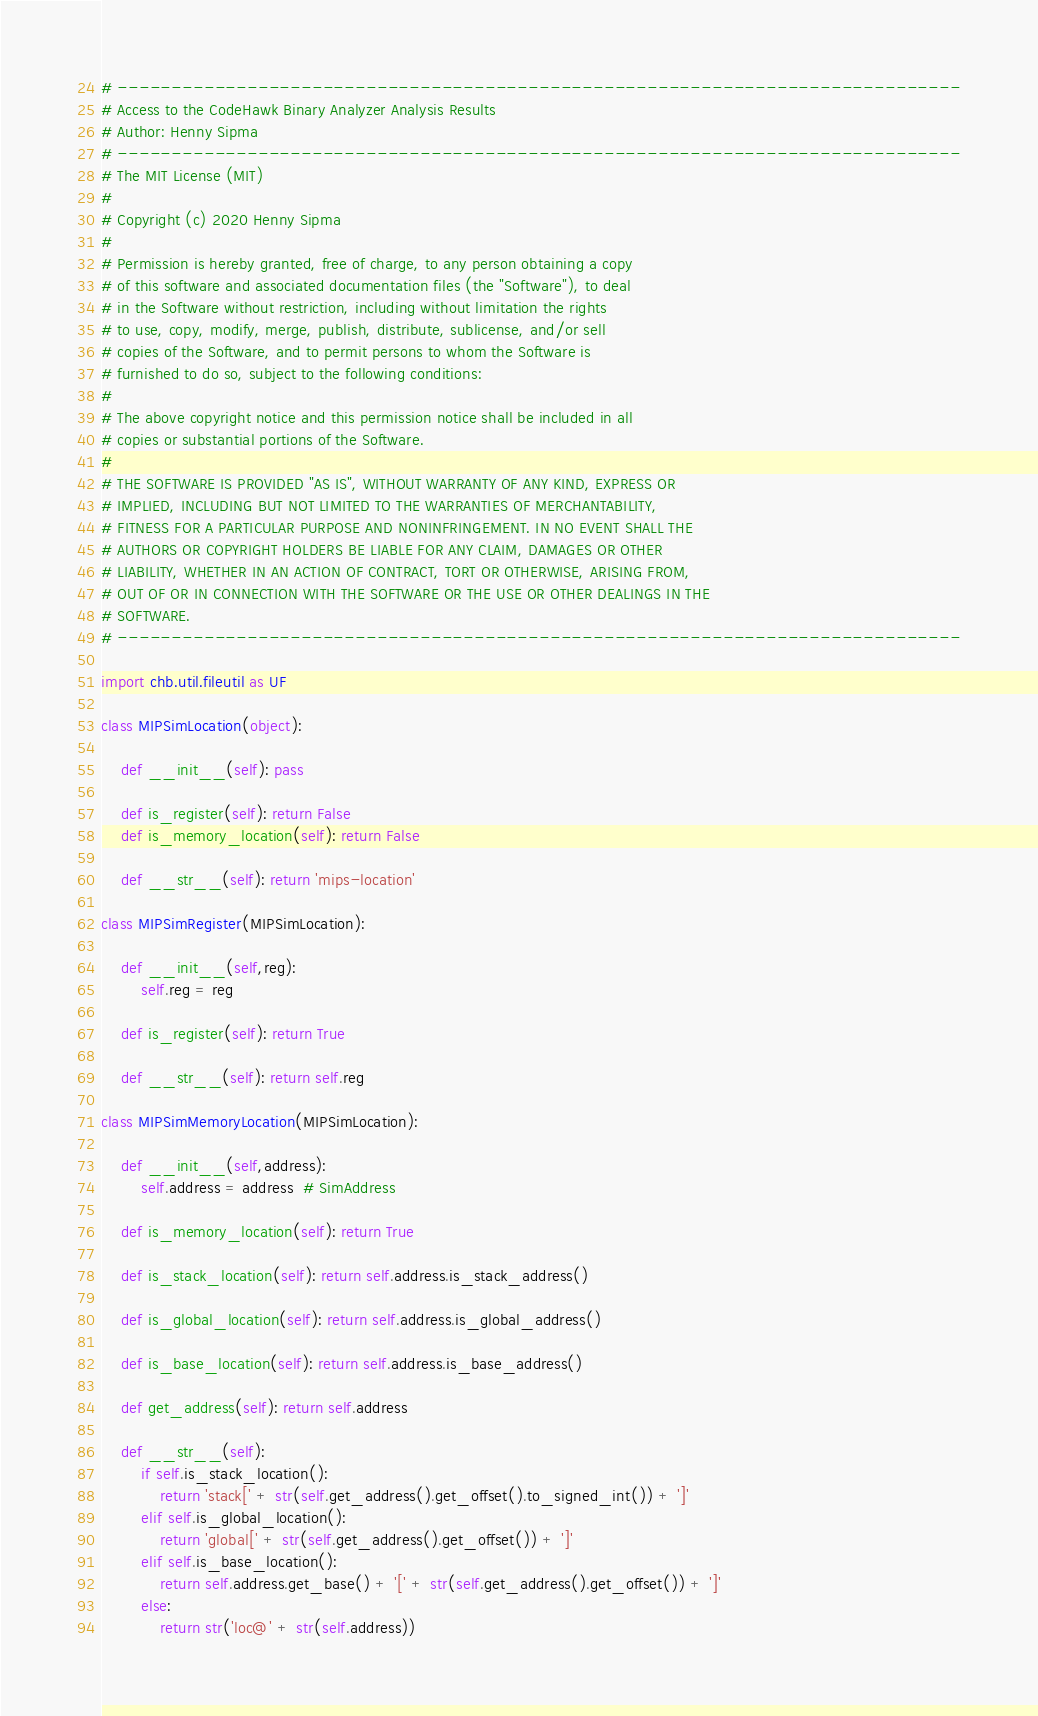Convert code to text. <code><loc_0><loc_0><loc_500><loc_500><_Python_># ------------------------------------------------------------------------------
# Access to the CodeHawk Binary Analyzer Analysis Results
# Author: Henny Sipma
# ------------------------------------------------------------------------------
# The MIT License (MIT)
#
# Copyright (c) 2020 Henny Sipma
#
# Permission is hereby granted, free of charge, to any person obtaining a copy
# of this software and associated documentation files (the "Software"), to deal
# in the Software without restriction, including without limitation the rights
# to use, copy, modify, merge, publish, distribute, sublicense, and/or sell
# copies of the Software, and to permit persons to whom the Software is
# furnished to do so, subject to the following conditions:
#
# The above copyright notice and this permission notice shall be included in all
# copies or substantial portions of the Software.
# 
# THE SOFTWARE IS PROVIDED "AS IS", WITHOUT WARRANTY OF ANY KIND, EXPRESS OR
# IMPLIED, INCLUDING BUT NOT LIMITED TO THE WARRANTIES OF MERCHANTABILITY,
# FITNESS FOR A PARTICULAR PURPOSE AND NONINFRINGEMENT. IN NO EVENT SHALL THE
# AUTHORS OR COPYRIGHT HOLDERS BE LIABLE FOR ANY CLAIM, DAMAGES OR OTHER
# LIABILITY, WHETHER IN AN ACTION OF CONTRACT, TORT OR OTHERWISE, ARISING FROM,
# OUT OF OR IN CONNECTION WITH THE SOFTWARE OR THE USE OR OTHER DEALINGS IN THE
# SOFTWARE.
# ------------------------------------------------------------------------------

import chb.util.fileutil as UF

class MIPSimLocation(object):

    def __init__(self): pass

    def is_register(self): return False
    def is_memory_location(self): return False

    def __str__(self): return 'mips-location'

class MIPSimRegister(MIPSimLocation):

    def __init__(self,reg):
        self.reg = reg

    def is_register(self): return True

    def __str__(self): return self.reg

class MIPSimMemoryLocation(MIPSimLocation):

    def __init__(self,address):
        self.address = address  # SimAddress

    def is_memory_location(self): return True

    def is_stack_location(self): return self.address.is_stack_address()

    def is_global_location(self): return self.address.is_global_address()

    def is_base_location(self): return self.address.is_base_address()

    def get_address(self): return self.address

    def __str__(self):
        if self.is_stack_location():
            return 'stack[' + str(self.get_address().get_offset().to_signed_int()) + ']'
        elif self.is_global_location():
            return 'global[' + str(self.get_address().get_offset()) + ']'
        elif self.is_base_location():
            return self.address.get_base() + '[' + str(self.get_address().get_offset()) + ']'
        else:
            return str('loc@' + str(self.address))
</code> 